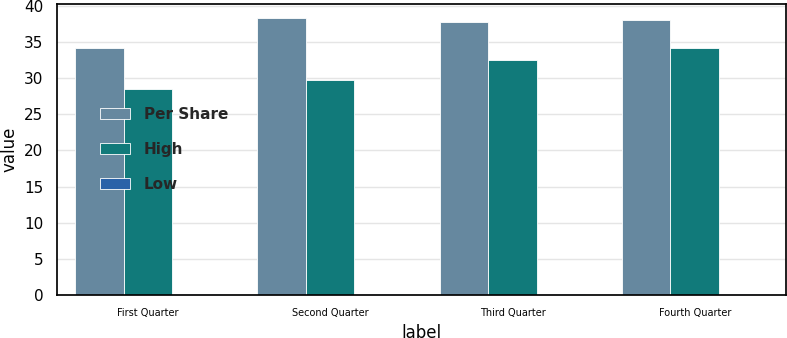<chart> <loc_0><loc_0><loc_500><loc_500><stacked_bar_chart><ecel><fcel>First Quarter<fcel>Second Quarter<fcel>Third Quarter<fcel>Fourth Quarter<nl><fcel>Per Share<fcel>34.24<fcel>38.43<fcel>37.83<fcel>38.04<nl><fcel>High<fcel>28.54<fcel>29.71<fcel>32.57<fcel>34.23<nl><fcel>Low<fcel>0.11<fcel>0.15<fcel>0.15<fcel>0.15<nl></chart> 